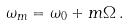Convert formula to latex. <formula><loc_0><loc_0><loc_500><loc_500>\omega _ { m } = \omega _ { 0 } + m \Omega \, .</formula> 